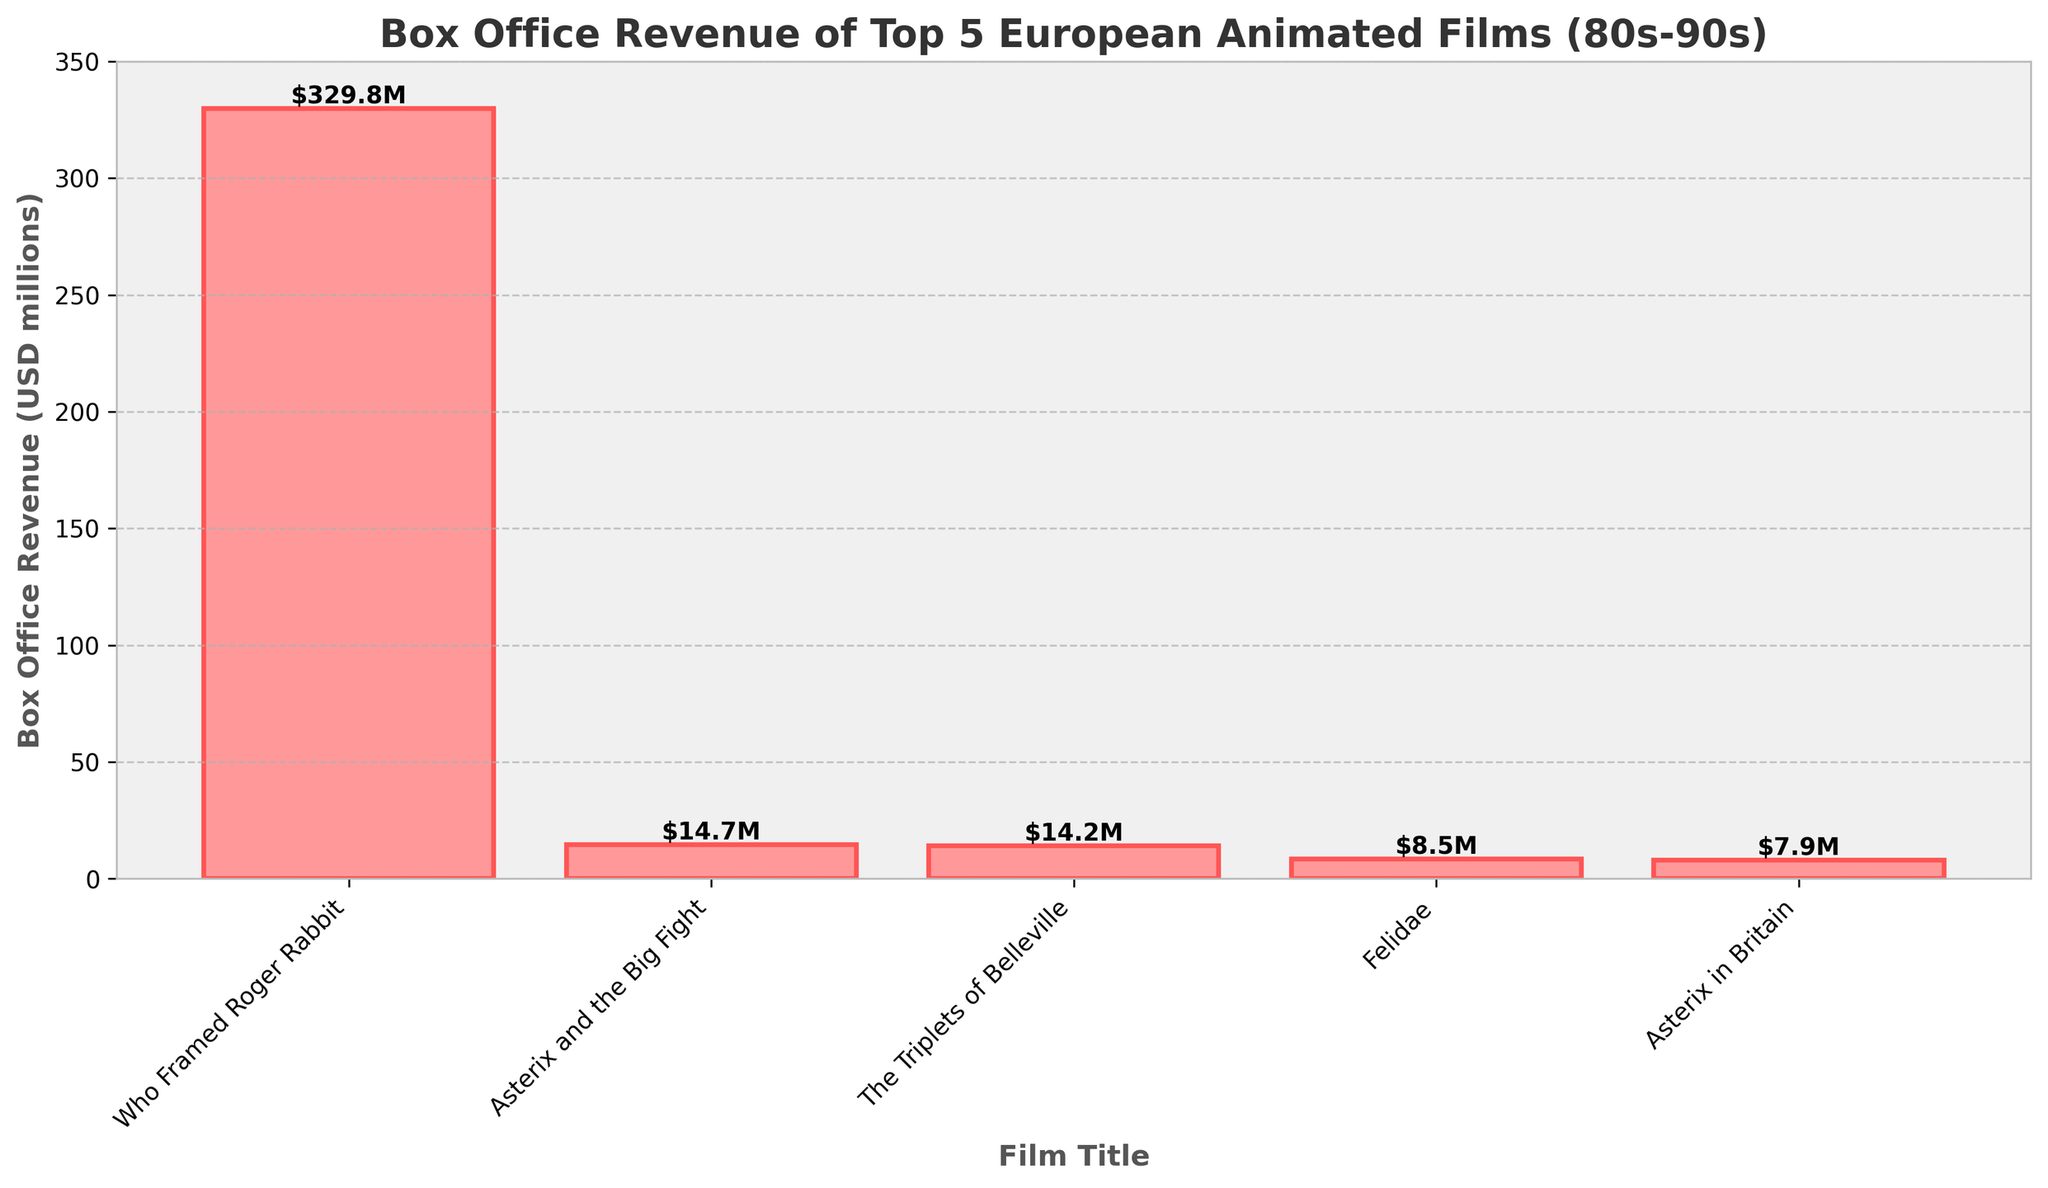What's the box office revenue of the highest-grossing film? The bar for "Who Framed Roger Rabbit" is the tallest, with a label indicating $329.8M, so this is the highest-grossing film among the five.
Answer: $329.8M Which film has the lowest box office revenue? The shortest bar corresponds to "Asterix in Britain," with a revenue label of $7.9M, indicating it has the lowest box office revenue.
Answer: $7.9M How much more did "Who Framed Roger Rabbit" earn compared to "Felidae"? "Who Framed Roger Rabbit" earned $329.8M, while "Felidae" earned $8.5M. The difference in their earnings is $329.8M - $8.5M.
Answer: $321.3M What is the total box office revenue of all the films combined? Adding all the revenues together: $329.8M + $14.7M + $14.2M + $8.5M + $7.9M = $375.1M
Answer: $375.1M Which two films have the closest box office revenues? "Asterix and the Big Fight" and "The Triplets of Belleville" have revenues of $14.7M and $14.2M, respectively, making their difference $0.5M, the smallest among the films.
Answer: "Asterix and the Big Fight" and "The Triplets of Belleville" Does any film's revenue exceed the total of the other four combined? The total revenue of the other four films is $14.7M + $14.2M + $8.5M + $7.9M = $45.3M. Since $329.8M (revenue of "Who Framed Roger Rabbit") is much greater than $45.3M, its revenue exceeds the total of the others.
Answer: Yes What is the average box office revenue of the films? To find the average, sum all revenues and divide by the number of films: ($329.8M + $14.7M + $14.2M + $8.5M + $7.9M) / 5 = $375.1M / 5
Answer: $75.02M Which film has the second highest box office revenue? The second highest bar corresponds to "Asterix and the Big Fight," with revenue of $14.7M, making it the second highest-grossing film.
Answer: "Asterix and the Big Fight" What is the median box office revenue of the films? The median is the middle value in an ordered list: [$7.9M, $8.5M, $14.2M, $14.7M, $329.8M]. The middle value is $14.2M.
Answer: $14.2M 